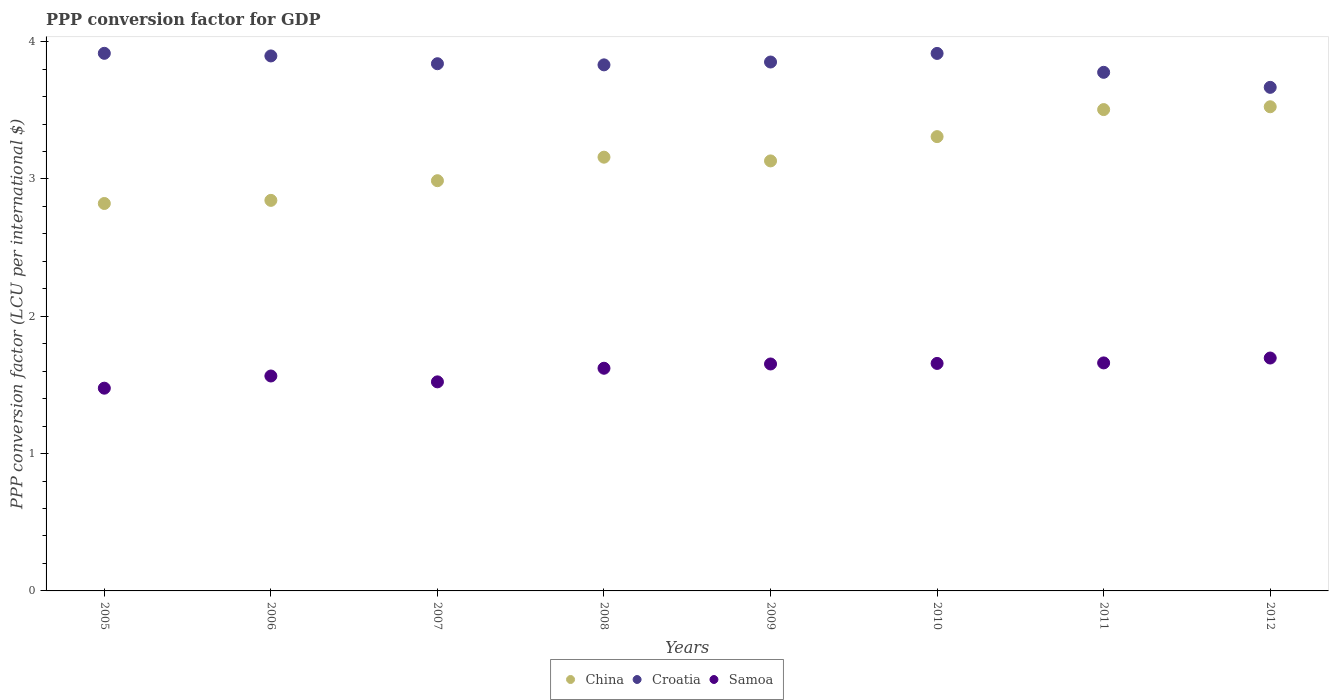Is the number of dotlines equal to the number of legend labels?
Your answer should be very brief. Yes. What is the PPP conversion factor for GDP in Samoa in 2010?
Give a very brief answer. 1.66. Across all years, what is the maximum PPP conversion factor for GDP in Samoa?
Offer a very short reply. 1.7. Across all years, what is the minimum PPP conversion factor for GDP in Samoa?
Make the answer very short. 1.48. In which year was the PPP conversion factor for GDP in Samoa maximum?
Your answer should be very brief. 2012. What is the total PPP conversion factor for GDP in Croatia in the graph?
Give a very brief answer. 30.69. What is the difference between the PPP conversion factor for GDP in China in 2006 and that in 2007?
Your response must be concise. -0.14. What is the difference between the PPP conversion factor for GDP in Croatia in 2008 and the PPP conversion factor for GDP in Samoa in 2010?
Provide a succinct answer. 2.17. What is the average PPP conversion factor for GDP in Samoa per year?
Offer a terse response. 1.61. In the year 2005, what is the difference between the PPP conversion factor for GDP in China and PPP conversion factor for GDP in Samoa?
Provide a short and direct response. 1.35. What is the ratio of the PPP conversion factor for GDP in Croatia in 2006 to that in 2008?
Your answer should be very brief. 1.02. Is the difference between the PPP conversion factor for GDP in China in 2009 and 2012 greater than the difference between the PPP conversion factor for GDP in Samoa in 2009 and 2012?
Ensure brevity in your answer.  No. What is the difference between the highest and the second highest PPP conversion factor for GDP in China?
Ensure brevity in your answer.  0.02. What is the difference between the highest and the lowest PPP conversion factor for GDP in Samoa?
Ensure brevity in your answer.  0.22. In how many years, is the PPP conversion factor for GDP in China greater than the average PPP conversion factor for GDP in China taken over all years?
Provide a short and direct response. 3. Does the PPP conversion factor for GDP in Samoa monotonically increase over the years?
Ensure brevity in your answer.  No. Is the PPP conversion factor for GDP in China strictly less than the PPP conversion factor for GDP in Croatia over the years?
Make the answer very short. Yes. How many years are there in the graph?
Your answer should be compact. 8. Are the values on the major ticks of Y-axis written in scientific E-notation?
Provide a short and direct response. No. Where does the legend appear in the graph?
Keep it short and to the point. Bottom center. How many legend labels are there?
Your answer should be very brief. 3. How are the legend labels stacked?
Offer a terse response. Horizontal. What is the title of the graph?
Offer a terse response. PPP conversion factor for GDP. What is the label or title of the Y-axis?
Your answer should be very brief. PPP conversion factor (LCU per international $). What is the PPP conversion factor (LCU per international $) of China in 2005?
Give a very brief answer. 2.82. What is the PPP conversion factor (LCU per international $) in Croatia in 2005?
Your answer should be compact. 3.92. What is the PPP conversion factor (LCU per international $) of Samoa in 2005?
Your answer should be very brief. 1.48. What is the PPP conversion factor (LCU per international $) of China in 2006?
Offer a terse response. 2.84. What is the PPP conversion factor (LCU per international $) of Croatia in 2006?
Offer a very short reply. 3.9. What is the PPP conversion factor (LCU per international $) of Samoa in 2006?
Your answer should be compact. 1.57. What is the PPP conversion factor (LCU per international $) of China in 2007?
Offer a very short reply. 2.99. What is the PPP conversion factor (LCU per international $) of Croatia in 2007?
Offer a terse response. 3.84. What is the PPP conversion factor (LCU per international $) in Samoa in 2007?
Ensure brevity in your answer.  1.52. What is the PPP conversion factor (LCU per international $) in China in 2008?
Offer a very short reply. 3.16. What is the PPP conversion factor (LCU per international $) in Croatia in 2008?
Keep it short and to the point. 3.83. What is the PPP conversion factor (LCU per international $) in Samoa in 2008?
Offer a terse response. 1.62. What is the PPP conversion factor (LCU per international $) in China in 2009?
Your response must be concise. 3.13. What is the PPP conversion factor (LCU per international $) of Croatia in 2009?
Your answer should be very brief. 3.85. What is the PPP conversion factor (LCU per international $) of Samoa in 2009?
Provide a succinct answer. 1.65. What is the PPP conversion factor (LCU per international $) of China in 2010?
Your answer should be compact. 3.31. What is the PPP conversion factor (LCU per international $) of Croatia in 2010?
Offer a very short reply. 3.91. What is the PPP conversion factor (LCU per international $) in Samoa in 2010?
Offer a very short reply. 1.66. What is the PPP conversion factor (LCU per international $) of China in 2011?
Offer a very short reply. 3.51. What is the PPP conversion factor (LCU per international $) of Croatia in 2011?
Give a very brief answer. 3.78. What is the PPP conversion factor (LCU per international $) in Samoa in 2011?
Provide a succinct answer. 1.66. What is the PPP conversion factor (LCU per international $) of China in 2012?
Your response must be concise. 3.53. What is the PPP conversion factor (LCU per international $) of Croatia in 2012?
Your answer should be compact. 3.67. What is the PPP conversion factor (LCU per international $) of Samoa in 2012?
Provide a short and direct response. 1.7. Across all years, what is the maximum PPP conversion factor (LCU per international $) in China?
Keep it short and to the point. 3.53. Across all years, what is the maximum PPP conversion factor (LCU per international $) of Croatia?
Provide a succinct answer. 3.92. Across all years, what is the maximum PPP conversion factor (LCU per international $) in Samoa?
Make the answer very short. 1.7. Across all years, what is the minimum PPP conversion factor (LCU per international $) in China?
Your answer should be very brief. 2.82. Across all years, what is the minimum PPP conversion factor (LCU per international $) of Croatia?
Provide a succinct answer. 3.67. Across all years, what is the minimum PPP conversion factor (LCU per international $) of Samoa?
Ensure brevity in your answer.  1.48. What is the total PPP conversion factor (LCU per international $) of China in the graph?
Offer a very short reply. 25.28. What is the total PPP conversion factor (LCU per international $) in Croatia in the graph?
Keep it short and to the point. 30.69. What is the total PPP conversion factor (LCU per international $) in Samoa in the graph?
Keep it short and to the point. 12.85. What is the difference between the PPP conversion factor (LCU per international $) of China in 2005 and that in 2006?
Ensure brevity in your answer.  -0.02. What is the difference between the PPP conversion factor (LCU per international $) of Croatia in 2005 and that in 2006?
Offer a very short reply. 0.02. What is the difference between the PPP conversion factor (LCU per international $) of Samoa in 2005 and that in 2006?
Your answer should be compact. -0.09. What is the difference between the PPP conversion factor (LCU per international $) of China in 2005 and that in 2007?
Your answer should be compact. -0.17. What is the difference between the PPP conversion factor (LCU per international $) in Croatia in 2005 and that in 2007?
Keep it short and to the point. 0.08. What is the difference between the PPP conversion factor (LCU per international $) in Samoa in 2005 and that in 2007?
Offer a very short reply. -0.05. What is the difference between the PPP conversion factor (LCU per international $) in China in 2005 and that in 2008?
Your answer should be very brief. -0.34. What is the difference between the PPP conversion factor (LCU per international $) of Croatia in 2005 and that in 2008?
Make the answer very short. 0.08. What is the difference between the PPP conversion factor (LCU per international $) of Samoa in 2005 and that in 2008?
Make the answer very short. -0.15. What is the difference between the PPP conversion factor (LCU per international $) in China in 2005 and that in 2009?
Provide a succinct answer. -0.31. What is the difference between the PPP conversion factor (LCU per international $) in Croatia in 2005 and that in 2009?
Keep it short and to the point. 0.06. What is the difference between the PPP conversion factor (LCU per international $) of Samoa in 2005 and that in 2009?
Keep it short and to the point. -0.18. What is the difference between the PPP conversion factor (LCU per international $) of China in 2005 and that in 2010?
Your response must be concise. -0.49. What is the difference between the PPP conversion factor (LCU per international $) in Croatia in 2005 and that in 2010?
Offer a terse response. 0. What is the difference between the PPP conversion factor (LCU per international $) of Samoa in 2005 and that in 2010?
Offer a terse response. -0.18. What is the difference between the PPP conversion factor (LCU per international $) in China in 2005 and that in 2011?
Your answer should be very brief. -0.68. What is the difference between the PPP conversion factor (LCU per international $) of Croatia in 2005 and that in 2011?
Ensure brevity in your answer.  0.14. What is the difference between the PPP conversion factor (LCU per international $) in Samoa in 2005 and that in 2011?
Your response must be concise. -0.18. What is the difference between the PPP conversion factor (LCU per international $) of China in 2005 and that in 2012?
Your answer should be very brief. -0.7. What is the difference between the PPP conversion factor (LCU per international $) of Croatia in 2005 and that in 2012?
Ensure brevity in your answer.  0.25. What is the difference between the PPP conversion factor (LCU per international $) of Samoa in 2005 and that in 2012?
Offer a terse response. -0.22. What is the difference between the PPP conversion factor (LCU per international $) of China in 2006 and that in 2007?
Offer a terse response. -0.14. What is the difference between the PPP conversion factor (LCU per international $) in Croatia in 2006 and that in 2007?
Offer a very short reply. 0.06. What is the difference between the PPP conversion factor (LCU per international $) of Samoa in 2006 and that in 2007?
Give a very brief answer. 0.04. What is the difference between the PPP conversion factor (LCU per international $) of China in 2006 and that in 2008?
Offer a terse response. -0.31. What is the difference between the PPP conversion factor (LCU per international $) of Croatia in 2006 and that in 2008?
Your answer should be compact. 0.07. What is the difference between the PPP conversion factor (LCU per international $) of Samoa in 2006 and that in 2008?
Give a very brief answer. -0.06. What is the difference between the PPP conversion factor (LCU per international $) in China in 2006 and that in 2009?
Make the answer very short. -0.29. What is the difference between the PPP conversion factor (LCU per international $) of Croatia in 2006 and that in 2009?
Ensure brevity in your answer.  0.04. What is the difference between the PPP conversion factor (LCU per international $) of Samoa in 2006 and that in 2009?
Make the answer very short. -0.09. What is the difference between the PPP conversion factor (LCU per international $) in China in 2006 and that in 2010?
Your answer should be very brief. -0.46. What is the difference between the PPP conversion factor (LCU per international $) of Croatia in 2006 and that in 2010?
Provide a short and direct response. -0.02. What is the difference between the PPP conversion factor (LCU per international $) of Samoa in 2006 and that in 2010?
Give a very brief answer. -0.09. What is the difference between the PPP conversion factor (LCU per international $) in China in 2006 and that in 2011?
Your response must be concise. -0.66. What is the difference between the PPP conversion factor (LCU per international $) in Croatia in 2006 and that in 2011?
Your answer should be compact. 0.12. What is the difference between the PPP conversion factor (LCU per international $) in Samoa in 2006 and that in 2011?
Offer a terse response. -0.1. What is the difference between the PPP conversion factor (LCU per international $) in China in 2006 and that in 2012?
Your response must be concise. -0.68. What is the difference between the PPP conversion factor (LCU per international $) in Croatia in 2006 and that in 2012?
Your answer should be compact. 0.23. What is the difference between the PPP conversion factor (LCU per international $) of Samoa in 2006 and that in 2012?
Give a very brief answer. -0.13. What is the difference between the PPP conversion factor (LCU per international $) of China in 2007 and that in 2008?
Provide a short and direct response. -0.17. What is the difference between the PPP conversion factor (LCU per international $) in Croatia in 2007 and that in 2008?
Make the answer very short. 0.01. What is the difference between the PPP conversion factor (LCU per international $) in Samoa in 2007 and that in 2008?
Provide a succinct answer. -0.1. What is the difference between the PPP conversion factor (LCU per international $) in China in 2007 and that in 2009?
Ensure brevity in your answer.  -0.14. What is the difference between the PPP conversion factor (LCU per international $) in Croatia in 2007 and that in 2009?
Offer a very short reply. -0.01. What is the difference between the PPP conversion factor (LCU per international $) of Samoa in 2007 and that in 2009?
Provide a succinct answer. -0.13. What is the difference between the PPP conversion factor (LCU per international $) of China in 2007 and that in 2010?
Offer a terse response. -0.32. What is the difference between the PPP conversion factor (LCU per international $) in Croatia in 2007 and that in 2010?
Your response must be concise. -0.07. What is the difference between the PPP conversion factor (LCU per international $) in Samoa in 2007 and that in 2010?
Offer a terse response. -0.13. What is the difference between the PPP conversion factor (LCU per international $) of China in 2007 and that in 2011?
Offer a terse response. -0.52. What is the difference between the PPP conversion factor (LCU per international $) in Croatia in 2007 and that in 2011?
Your answer should be very brief. 0.06. What is the difference between the PPP conversion factor (LCU per international $) of Samoa in 2007 and that in 2011?
Ensure brevity in your answer.  -0.14. What is the difference between the PPP conversion factor (LCU per international $) in China in 2007 and that in 2012?
Provide a succinct answer. -0.54. What is the difference between the PPP conversion factor (LCU per international $) of Croatia in 2007 and that in 2012?
Your answer should be compact. 0.17. What is the difference between the PPP conversion factor (LCU per international $) of Samoa in 2007 and that in 2012?
Provide a succinct answer. -0.17. What is the difference between the PPP conversion factor (LCU per international $) of China in 2008 and that in 2009?
Provide a short and direct response. 0.03. What is the difference between the PPP conversion factor (LCU per international $) in Croatia in 2008 and that in 2009?
Your response must be concise. -0.02. What is the difference between the PPP conversion factor (LCU per international $) of Samoa in 2008 and that in 2009?
Offer a very short reply. -0.03. What is the difference between the PPP conversion factor (LCU per international $) in China in 2008 and that in 2010?
Offer a very short reply. -0.15. What is the difference between the PPP conversion factor (LCU per international $) in Croatia in 2008 and that in 2010?
Offer a very short reply. -0.08. What is the difference between the PPP conversion factor (LCU per international $) in Samoa in 2008 and that in 2010?
Your answer should be very brief. -0.04. What is the difference between the PPP conversion factor (LCU per international $) in China in 2008 and that in 2011?
Your response must be concise. -0.35. What is the difference between the PPP conversion factor (LCU per international $) in Croatia in 2008 and that in 2011?
Keep it short and to the point. 0.05. What is the difference between the PPP conversion factor (LCU per international $) of Samoa in 2008 and that in 2011?
Ensure brevity in your answer.  -0.04. What is the difference between the PPP conversion factor (LCU per international $) of China in 2008 and that in 2012?
Keep it short and to the point. -0.37. What is the difference between the PPP conversion factor (LCU per international $) in Croatia in 2008 and that in 2012?
Offer a very short reply. 0.16. What is the difference between the PPP conversion factor (LCU per international $) in Samoa in 2008 and that in 2012?
Make the answer very short. -0.07. What is the difference between the PPP conversion factor (LCU per international $) of China in 2009 and that in 2010?
Make the answer very short. -0.18. What is the difference between the PPP conversion factor (LCU per international $) of Croatia in 2009 and that in 2010?
Your answer should be very brief. -0.06. What is the difference between the PPP conversion factor (LCU per international $) of Samoa in 2009 and that in 2010?
Offer a terse response. -0. What is the difference between the PPP conversion factor (LCU per international $) of China in 2009 and that in 2011?
Provide a short and direct response. -0.37. What is the difference between the PPP conversion factor (LCU per international $) of Croatia in 2009 and that in 2011?
Give a very brief answer. 0.07. What is the difference between the PPP conversion factor (LCU per international $) in Samoa in 2009 and that in 2011?
Your response must be concise. -0.01. What is the difference between the PPP conversion factor (LCU per international $) in China in 2009 and that in 2012?
Provide a short and direct response. -0.39. What is the difference between the PPP conversion factor (LCU per international $) in Croatia in 2009 and that in 2012?
Provide a succinct answer. 0.18. What is the difference between the PPP conversion factor (LCU per international $) in Samoa in 2009 and that in 2012?
Give a very brief answer. -0.04. What is the difference between the PPP conversion factor (LCU per international $) in China in 2010 and that in 2011?
Your answer should be very brief. -0.2. What is the difference between the PPP conversion factor (LCU per international $) in Croatia in 2010 and that in 2011?
Offer a terse response. 0.14. What is the difference between the PPP conversion factor (LCU per international $) of Samoa in 2010 and that in 2011?
Your answer should be very brief. -0. What is the difference between the PPP conversion factor (LCU per international $) of China in 2010 and that in 2012?
Your answer should be compact. -0.22. What is the difference between the PPP conversion factor (LCU per international $) in Croatia in 2010 and that in 2012?
Offer a terse response. 0.25. What is the difference between the PPP conversion factor (LCU per international $) in Samoa in 2010 and that in 2012?
Offer a terse response. -0.04. What is the difference between the PPP conversion factor (LCU per international $) in China in 2011 and that in 2012?
Offer a terse response. -0.02. What is the difference between the PPP conversion factor (LCU per international $) in Croatia in 2011 and that in 2012?
Your answer should be very brief. 0.11. What is the difference between the PPP conversion factor (LCU per international $) of Samoa in 2011 and that in 2012?
Your answer should be compact. -0.04. What is the difference between the PPP conversion factor (LCU per international $) in China in 2005 and the PPP conversion factor (LCU per international $) in Croatia in 2006?
Keep it short and to the point. -1.07. What is the difference between the PPP conversion factor (LCU per international $) in China in 2005 and the PPP conversion factor (LCU per international $) in Samoa in 2006?
Your response must be concise. 1.26. What is the difference between the PPP conversion factor (LCU per international $) of Croatia in 2005 and the PPP conversion factor (LCU per international $) of Samoa in 2006?
Your answer should be very brief. 2.35. What is the difference between the PPP conversion factor (LCU per international $) of China in 2005 and the PPP conversion factor (LCU per international $) of Croatia in 2007?
Your response must be concise. -1.02. What is the difference between the PPP conversion factor (LCU per international $) of China in 2005 and the PPP conversion factor (LCU per international $) of Samoa in 2007?
Give a very brief answer. 1.3. What is the difference between the PPP conversion factor (LCU per international $) in Croatia in 2005 and the PPP conversion factor (LCU per international $) in Samoa in 2007?
Offer a very short reply. 2.39. What is the difference between the PPP conversion factor (LCU per international $) of China in 2005 and the PPP conversion factor (LCU per international $) of Croatia in 2008?
Keep it short and to the point. -1.01. What is the difference between the PPP conversion factor (LCU per international $) of China in 2005 and the PPP conversion factor (LCU per international $) of Samoa in 2008?
Ensure brevity in your answer.  1.2. What is the difference between the PPP conversion factor (LCU per international $) in Croatia in 2005 and the PPP conversion factor (LCU per international $) in Samoa in 2008?
Provide a short and direct response. 2.29. What is the difference between the PPP conversion factor (LCU per international $) of China in 2005 and the PPP conversion factor (LCU per international $) of Croatia in 2009?
Provide a short and direct response. -1.03. What is the difference between the PPP conversion factor (LCU per international $) of China in 2005 and the PPP conversion factor (LCU per international $) of Samoa in 2009?
Your response must be concise. 1.17. What is the difference between the PPP conversion factor (LCU per international $) in Croatia in 2005 and the PPP conversion factor (LCU per international $) in Samoa in 2009?
Your answer should be very brief. 2.26. What is the difference between the PPP conversion factor (LCU per international $) of China in 2005 and the PPP conversion factor (LCU per international $) of Croatia in 2010?
Offer a very short reply. -1.09. What is the difference between the PPP conversion factor (LCU per international $) of China in 2005 and the PPP conversion factor (LCU per international $) of Samoa in 2010?
Ensure brevity in your answer.  1.16. What is the difference between the PPP conversion factor (LCU per international $) of Croatia in 2005 and the PPP conversion factor (LCU per international $) of Samoa in 2010?
Make the answer very short. 2.26. What is the difference between the PPP conversion factor (LCU per international $) in China in 2005 and the PPP conversion factor (LCU per international $) in Croatia in 2011?
Provide a short and direct response. -0.96. What is the difference between the PPP conversion factor (LCU per international $) in China in 2005 and the PPP conversion factor (LCU per international $) in Samoa in 2011?
Provide a short and direct response. 1.16. What is the difference between the PPP conversion factor (LCU per international $) of Croatia in 2005 and the PPP conversion factor (LCU per international $) of Samoa in 2011?
Keep it short and to the point. 2.25. What is the difference between the PPP conversion factor (LCU per international $) of China in 2005 and the PPP conversion factor (LCU per international $) of Croatia in 2012?
Give a very brief answer. -0.85. What is the difference between the PPP conversion factor (LCU per international $) of China in 2005 and the PPP conversion factor (LCU per international $) of Samoa in 2012?
Offer a terse response. 1.13. What is the difference between the PPP conversion factor (LCU per international $) of Croatia in 2005 and the PPP conversion factor (LCU per international $) of Samoa in 2012?
Ensure brevity in your answer.  2.22. What is the difference between the PPP conversion factor (LCU per international $) of China in 2006 and the PPP conversion factor (LCU per international $) of Croatia in 2007?
Your answer should be very brief. -1. What is the difference between the PPP conversion factor (LCU per international $) of China in 2006 and the PPP conversion factor (LCU per international $) of Samoa in 2007?
Offer a very short reply. 1.32. What is the difference between the PPP conversion factor (LCU per international $) of Croatia in 2006 and the PPP conversion factor (LCU per international $) of Samoa in 2007?
Keep it short and to the point. 2.37. What is the difference between the PPP conversion factor (LCU per international $) of China in 2006 and the PPP conversion factor (LCU per international $) of Croatia in 2008?
Your answer should be very brief. -0.99. What is the difference between the PPP conversion factor (LCU per international $) in China in 2006 and the PPP conversion factor (LCU per international $) in Samoa in 2008?
Ensure brevity in your answer.  1.22. What is the difference between the PPP conversion factor (LCU per international $) of Croatia in 2006 and the PPP conversion factor (LCU per international $) of Samoa in 2008?
Provide a short and direct response. 2.27. What is the difference between the PPP conversion factor (LCU per international $) in China in 2006 and the PPP conversion factor (LCU per international $) in Croatia in 2009?
Your answer should be very brief. -1.01. What is the difference between the PPP conversion factor (LCU per international $) of China in 2006 and the PPP conversion factor (LCU per international $) of Samoa in 2009?
Your answer should be compact. 1.19. What is the difference between the PPP conversion factor (LCU per international $) in Croatia in 2006 and the PPP conversion factor (LCU per international $) in Samoa in 2009?
Provide a short and direct response. 2.24. What is the difference between the PPP conversion factor (LCU per international $) of China in 2006 and the PPP conversion factor (LCU per international $) of Croatia in 2010?
Your response must be concise. -1.07. What is the difference between the PPP conversion factor (LCU per international $) in China in 2006 and the PPP conversion factor (LCU per international $) in Samoa in 2010?
Your response must be concise. 1.19. What is the difference between the PPP conversion factor (LCU per international $) in Croatia in 2006 and the PPP conversion factor (LCU per international $) in Samoa in 2010?
Ensure brevity in your answer.  2.24. What is the difference between the PPP conversion factor (LCU per international $) of China in 2006 and the PPP conversion factor (LCU per international $) of Croatia in 2011?
Give a very brief answer. -0.93. What is the difference between the PPP conversion factor (LCU per international $) in China in 2006 and the PPP conversion factor (LCU per international $) in Samoa in 2011?
Your answer should be very brief. 1.18. What is the difference between the PPP conversion factor (LCU per international $) in Croatia in 2006 and the PPP conversion factor (LCU per international $) in Samoa in 2011?
Your answer should be compact. 2.24. What is the difference between the PPP conversion factor (LCU per international $) in China in 2006 and the PPP conversion factor (LCU per international $) in Croatia in 2012?
Offer a terse response. -0.82. What is the difference between the PPP conversion factor (LCU per international $) of China in 2006 and the PPP conversion factor (LCU per international $) of Samoa in 2012?
Give a very brief answer. 1.15. What is the difference between the PPP conversion factor (LCU per international $) in Croatia in 2006 and the PPP conversion factor (LCU per international $) in Samoa in 2012?
Keep it short and to the point. 2.2. What is the difference between the PPP conversion factor (LCU per international $) in China in 2007 and the PPP conversion factor (LCU per international $) in Croatia in 2008?
Provide a short and direct response. -0.84. What is the difference between the PPP conversion factor (LCU per international $) in China in 2007 and the PPP conversion factor (LCU per international $) in Samoa in 2008?
Your answer should be compact. 1.37. What is the difference between the PPP conversion factor (LCU per international $) of Croatia in 2007 and the PPP conversion factor (LCU per international $) of Samoa in 2008?
Give a very brief answer. 2.22. What is the difference between the PPP conversion factor (LCU per international $) in China in 2007 and the PPP conversion factor (LCU per international $) in Croatia in 2009?
Your response must be concise. -0.86. What is the difference between the PPP conversion factor (LCU per international $) in China in 2007 and the PPP conversion factor (LCU per international $) in Samoa in 2009?
Offer a very short reply. 1.33. What is the difference between the PPP conversion factor (LCU per international $) in Croatia in 2007 and the PPP conversion factor (LCU per international $) in Samoa in 2009?
Provide a short and direct response. 2.19. What is the difference between the PPP conversion factor (LCU per international $) in China in 2007 and the PPP conversion factor (LCU per international $) in Croatia in 2010?
Offer a terse response. -0.93. What is the difference between the PPP conversion factor (LCU per international $) in China in 2007 and the PPP conversion factor (LCU per international $) in Samoa in 2010?
Give a very brief answer. 1.33. What is the difference between the PPP conversion factor (LCU per international $) in Croatia in 2007 and the PPP conversion factor (LCU per international $) in Samoa in 2010?
Provide a succinct answer. 2.18. What is the difference between the PPP conversion factor (LCU per international $) of China in 2007 and the PPP conversion factor (LCU per international $) of Croatia in 2011?
Provide a succinct answer. -0.79. What is the difference between the PPP conversion factor (LCU per international $) in China in 2007 and the PPP conversion factor (LCU per international $) in Samoa in 2011?
Your answer should be very brief. 1.33. What is the difference between the PPP conversion factor (LCU per international $) of Croatia in 2007 and the PPP conversion factor (LCU per international $) of Samoa in 2011?
Your answer should be compact. 2.18. What is the difference between the PPP conversion factor (LCU per international $) in China in 2007 and the PPP conversion factor (LCU per international $) in Croatia in 2012?
Your response must be concise. -0.68. What is the difference between the PPP conversion factor (LCU per international $) of China in 2007 and the PPP conversion factor (LCU per international $) of Samoa in 2012?
Your answer should be compact. 1.29. What is the difference between the PPP conversion factor (LCU per international $) in Croatia in 2007 and the PPP conversion factor (LCU per international $) in Samoa in 2012?
Make the answer very short. 2.14. What is the difference between the PPP conversion factor (LCU per international $) in China in 2008 and the PPP conversion factor (LCU per international $) in Croatia in 2009?
Your answer should be compact. -0.69. What is the difference between the PPP conversion factor (LCU per international $) in China in 2008 and the PPP conversion factor (LCU per international $) in Samoa in 2009?
Your answer should be very brief. 1.51. What is the difference between the PPP conversion factor (LCU per international $) in Croatia in 2008 and the PPP conversion factor (LCU per international $) in Samoa in 2009?
Provide a succinct answer. 2.18. What is the difference between the PPP conversion factor (LCU per international $) in China in 2008 and the PPP conversion factor (LCU per international $) in Croatia in 2010?
Offer a very short reply. -0.76. What is the difference between the PPP conversion factor (LCU per international $) in China in 2008 and the PPP conversion factor (LCU per international $) in Samoa in 2010?
Ensure brevity in your answer.  1.5. What is the difference between the PPP conversion factor (LCU per international $) in Croatia in 2008 and the PPP conversion factor (LCU per international $) in Samoa in 2010?
Your answer should be very brief. 2.17. What is the difference between the PPP conversion factor (LCU per international $) of China in 2008 and the PPP conversion factor (LCU per international $) of Croatia in 2011?
Your response must be concise. -0.62. What is the difference between the PPP conversion factor (LCU per international $) of China in 2008 and the PPP conversion factor (LCU per international $) of Samoa in 2011?
Provide a succinct answer. 1.5. What is the difference between the PPP conversion factor (LCU per international $) of Croatia in 2008 and the PPP conversion factor (LCU per international $) of Samoa in 2011?
Keep it short and to the point. 2.17. What is the difference between the PPP conversion factor (LCU per international $) in China in 2008 and the PPP conversion factor (LCU per international $) in Croatia in 2012?
Ensure brevity in your answer.  -0.51. What is the difference between the PPP conversion factor (LCU per international $) in China in 2008 and the PPP conversion factor (LCU per international $) in Samoa in 2012?
Keep it short and to the point. 1.46. What is the difference between the PPP conversion factor (LCU per international $) in Croatia in 2008 and the PPP conversion factor (LCU per international $) in Samoa in 2012?
Your answer should be compact. 2.14. What is the difference between the PPP conversion factor (LCU per international $) of China in 2009 and the PPP conversion factor (LCU per international $) of Croatia in 2010?
Provide a short and direct response. -0.78. What is the difference between the PPP conversion factor (LCU per international $) of China in 2009 and the PPP conversion factor (LCU per international $) of Samoa in 2010?
Give a very brief answer. 1.47. What is the difference between the PPP conversion factor (LCU per international $) of Croatia in 2009 and the PPP conversion factor (LCU per international $) of Samoa in 2010?
Give a very brief answer. 2.2. What is the difference between the PPP conversion factor (LCU per international $) of China in 2009 and the PPP conversion factor (LCU per international $) of Croatia in 2011?
Make the answer very short. -0.65. What is the difference between the PPP conversion factor (LCU per international $) in China in 2009 and the PPP conversion factor (LCU per international $) in Samoa in 2011?
Give a very brief answer. 1.47. What is the difference between the PPP conversion factor (LCU per international $) of Croatia in 2009 and the PPP conversion factor (LCU per international $) of Samoa in 2011?
Give a very brief answer. 2.19. What is the difference between the PPP conversion factor (LCU per international $) of China in 2009 and the PPP conversion factor (LCU per international $) of Croatia in 2012?
Give a very brief answer. -0.54. What is the difference between the PPP conversion factor (LCU per international $) of China in 2009 and the PPP conversion factor (LCU per international $) of Samoa in 2012?
Make the answer very short. 1.44. What is the difference between the PPP conversion factor (LCU per international $) of Croatia in 2009 and the PPP conversion factor (LCU per international $) of Samoa in 2012?
Keep it short and to the point. 2.16. What is the difference between the PPP conversion factor (LCU per international $) in China in 2010 and the PPP conversion factor (LCU per international $) in Croatia in 2011?
Your answer should be very brief. -0.47. What is the difference between the PPP conversion factor (LCU per international $) of China in 2010 and the PPP conversion factor (LCU per international $) of Samoa in 2011?
Make the answer very short. 1.65. What is the difference between the PPP conversion factor (LCU per international $) of Croatia in 2010 and the PPP conversion factor (LCU per international $) of Samoa in 2011?
Make the answer very short. 2.25. What is the difference between the PPP conversion factor (LCU per international $) in China in 2010 and the PPP conversion factor (LCU per international $) in Croatia in 2012?
Give a very brief answer. -0.36. What is the difference between the PPP conversion factor (LCU per international $) in China in 2010 and the PPP conversion factor (LCU per international $) in Samoa in 2012?
Offer a terse response. 1.61. What is the difference between the PPP conversion factor (LCU per international $) in Croatia in 2010 and the PPP conversion factor (LCU per international $) in Samoa in 2012?
Provide a succinct answer. 2.22. What is the difference between the PPP conversion factor (LCU per international $) in China in 2011 and the PPP conversion factor (LCU per international $) in Croatia in 2012?
Your answer should be very brief. -0.16. What is the difference between the PPP conversion factor (LCU per international $) in China in 2011 and the PPP conversion factor (LCU per international $) in Samoa in 2012?
Keep it short and to the point. 1.81. What is the difference between the PPP conversion factor (LCU per international $) of Croatia in 2011 and the PPP conversion factor (LCU per international $) of Samoa in 2012?
Give a very brief answer. 2.08. What is the average PPP conversion factor (LCU per international $) in China per year?
Provide a short and direct response. 3.16. What is the average PPP conversion factor (LCU per international $) of Croatia per year?
Provide a succinct answer. 3.84. What is the average PPP conversion factor (LCU per international $) of Samoa per year?
Keep it short and to the point. 1.61. In the year 2005, what is the difference between the PPP conversion factor (LCU per international $) in China and PPP conversion factor (LCU per international $) in Croatia?
Provide a succinct answer. -1.09. In the year 2005, what is the difference between the PPP conversion factor (LCU per international $) in China and PPP conversion factor (LCU per international $) in Samoa?
Give a very brief answer. 1.35. In the year 2005, what is the difference between the PPP conversion factor (LCU per international $) of Croatia and PPP conversion factor (LCU per international $) of Samoa?
Provide a succinct answer. 2.44. In the year 2006, what is the difference between the PPP conversion factor (LCU per international $) in China and PPP conversion factor (LCU per international $) in Croatia?
Offer a terse response. -1.05. In the year 2006, what is the difference between the PPP conversion factor (LCU per international $) of China and PPP conversion factor (LCU per international $) of Samoa?
Keep it short and to the point. 1.28. In the year 2006, what is the difference between the PPP conversion factor (LCU per international $) in Croatia and PPP conversion factor (LCU per international $) in Samoa?
Provide a short and direct response. 2.33. In the year 2007, what is the difference between the PPP conversion factor (LCU per international $) in China and PPP conversion factor (LCU per international $) in Croatia?
Provide a succinct answer. -0.85. In the year 2007, what is the difference between the PPP conversion factor (LCU per international $) in China and PPP conversion factor (LCU per international $) in Samoa?
Your response must be concise. 1.47. In the year 2007, what is the difference between the PPP conversion factor (LCU per international $) of Croatia and PPP conversion factor (LCU per international $) of Samoa?
Make the answer very short. 2.32. In the year 2008, what is the difference between the PPP conversion factor (LCU per international $) of China and PPP conversion factor (LCU per international $) of Croatia?
Provide a succinct answer. -0.67. In the year 2008, what is the difference between the PPP conversion factor (LCU per international $) in China and PPP conversion factor (LCU per international $) in Samoa?
Your answer should be compact. 1.54. In the year 2008, what is the difference between the PPP conversion factor (LCU per international $) of Croatia and PPP conversion factor (LCU per international $) of Samoa?
Give a very brief answer. 2.21. In the year 2009, what is the difference between the PPP conversion factor (LCU per international $) of China and PPP conversion factor (LCU per international $) of Croatia?
Provide a succinct answer. -0.72. In the year 2009, what is the difference between the PPP conversion factor (LCU per international $) of China and PPP conversion factor (LCU per international $) of Samoa?
Provide a short and direct response. 1.48. In the year 2009, what is the difference between the PPP conversion factor (LCU per international $) of Croatia and PPP conversion factor (LCU per international $) of Samoa?
Offer a terse response. 2.2. In the year 2010, what is the difference between the PPP conversion factor (LCU per international $) in China and PPP conversion factor (LCU per international $) in Croatia?
Keep it short and to the point. -0.61. In the year 2010, what is the difference between the PPP conversion factor (LCU per international $) in China and PPP conversion factor (LCU per international $) in Samoa?
Keep it short and to the point. 1.65. In the year 2010, what is the difference between the PPP conversion factor (LCU per international $) of Croatia and PPP conversion factor (LCU per international $) of Samoa?
Give a very brief answer. 2.26. In the year 2011, what is the difference between the PPP conversion factor (LCU per international $) of China and PPP conversion factor (LCU per international $) of Croatia?
Your response must be concise. -0.27. In the year 2011, what is the difference between the PPP conversion factor (LCU per international $) of China and PPP conversion factor (LCU per international $) of Samoa?
Offer a terse response. 1.84. In the year 2011, what is the difference between the PPP conversion factor (LCU per international $) of Croatia and PPP conversion factor (LCU per international $) of Samoa?
Ensure brevity in your answer.  2.12. In the year 2012, what is the difference between the PPP conversion factor (LCU per international $) of China and PPP conversion factor (LCU per international $) of Croatia?
Offer a very short reply. -0.14. In the year 2012, what is the difference between the PPP conversion factor (LCU per international $) of China and PPP conversion factor (LCU per international $) of Samoa?
Your answer should be compact. 1.83. In the year 2012, what is the difference between the PPP conversion factor (LCU per international $) of Croatia and PPP conversion factor (LCU per international $) of Samoa?
Provide a succinct answer. 1.97. What is the ratio of the PPP conversion factor (LCU per international $) of Samoa in 2005 to that in 2006?
Provide a short and direct response. 0.94. What is the ratio of the PPP conversion factor (LCU per international $) of China in 2005 to that in 2007?
Your answer should be compact. 0.94. What is the ratio of the PPP conversion factor (LCU per international $) in Croatia in 2005 to that in 2007?
Ensure brevity in your answer.  1.02. What is the ratio of the PPP conversion factor (LCU per international $) in Samoa in 2005 to that in 2007?
Your response must be concise. 0.97. What is the ratio of the PPP conversion factor (LCU per international $) of China in 2005 to that in 2008?
Make the answer very short. 0.89. What is the ratio of the PPP conversion factor (LCU per international $) in Croatia in 2005 to that in 2008?
Make the answer very short. 1.02. What is the ratio of the PPP conversion factor (LCU per international $) of Samoa in 2005 to that in 2008?
Provide a short and direct response. 0.91. What is the ratio of the PPP conversion factor (LCU per international $) in China in 2005 to that in 2009?
Your answer should be very brief. 0.9. What is the ratio of the PPP conversion factor (LCU per international $) in Croatia in 2005 to that in 2009?
Keep it short and to the point. 1.02. What is the ratio of the PPP conversion factor (LCU per international $) in Samoa in 2005 to that in 2009?
Provide a short and direct response. 0.89. What is the ratio of the PPP conversion factor (LCU per international $) in China in 2005 to that in 2010?
Provide a succinct answer. 0.85. What is the ratio of the PPP conversion factor (LCU per international $) of Croatia in 2005 to that in 2010?
Make the answer very short. 1. What is the ratio of the PPP conversion factor (LCU per international $) of Samoa in 2005 to that in 2010?
Provide a succinct answer. 0.89. What is the ratio of the PPP conversion factor (LCU per international $) in China in 2005 to that in 2011?
Give a very brief answer. 0.8. What is the ratio of the PPP conversion factor (LCU per international $) of Croatia in 2005 to that in 2011?
Your response must be concise. 1.04. What is the ratio of the PPP conversion factor (LCU per international $) of Samoa in 2005 to that in 2011?
Make the answer very short. 0.89. What is the ratio of the PPP conversion factor (LCU per international $) of China in 2005 to that in 2012?
Your answer should be compact. 0.8. What is the ratio of the PPP conversion factor (LCU per international $) of Croatia in 2005 to that in 2012?
Ensure brevity in your answer.  1.07. What is the ratio of the PPP conversion factor (LCU per international $) of Samoa in 2005 to that in 2012?
Your response must be concise. 0.87. What is the ratio of the PPP conversion factor (LCU per international $) of China in 2006 to that in 2007?
Make the answer very short. 0.95. What is the ratio of the PPP conversion factor (LCU per international $) of Croatia in 2006 to that in 2007?
Provide a succinct answer. 1.01. What is the ratio of the PPP conversion factor (LCU per international $) of Samoa in 2006 to that in 2007?
Offer a very short reply. 1.03. What is the ratio of the PPP conversion factor (LCU per international $) in China in 2006 to that in 2008?
Make the answer very short. 0.9. What is the ratio of the PPP conversion factor (LCU per international $) of Samoa in 2006 to that in 2008?
Your answer should be compact. 0.97. What is the ratio of the PPP conversion factor (LCU per international $) in China in 2006 to that in 2009?
Your answer should be very brief. 0.91. What is the ratio of the PPP conversion factor (LCU per international $) in Croatia in 2006 to that in 2009?
Offer a terse response. 1.01. What is the ratio of the PPP conversion factor (LCU per international $) of Samoa in 2006 to that in 2009?
Offer a terse response. 0.95. What is the ratio of the PPP conversion factor (LCU per international $) of China in 2006 to that in 2010?
Provide a succinct answer. 0.86. What is the ratio of the PPP conversion factor (LCU per international $) of Croatia in 2006 to that in 2010?
Make the answer very short. 1. What is the ratio of the PPP conversion factor (LCU per international $) in Samoa in 2006 to that in 2010?
Offer a very short reply. 0.94. What is the ratio of the PPP conversion factor (LCU per international $) in China in 2006 to that in 2011?
Offer a very short reply. 0.81. What is the ratio of the PPP conversion factor (LCU per international $) of Croatia in 2006 to that in 2011?
Offer a very short reply. 1.03. What is the ratio of the PPP conversion factor (LCU per international $) of Samoa in 2006 to that in 2011?
Provide a short and direct response. 0.94. What is the ratio of the PPP conversion factor (LCU per international $) in China in 2006 to that in 2012?
Make the answer very short. 0.81. What is the ratio of the PPP conversion factor (LCU per international $) in Croatia in 2006 to that in 2012?
Give a very brief answer. 1.06. What is the ratio of the PPP conversion factor (LCU per international $) in Samoa in 2006 to that in 2012?
Offer a very short reply. 0.92. What is the ratio of the PPP conversion factor (LCU per international $) of China in 2007 to that in 2008?
Offer a very short reply. 0.95. What is the ratio of the PPP conversion factor (LCU per international $) in Croatia in 2007 to that in 2008?
Offer a very short reply. 1. What is the ratio of the PPP conversion factor (LCU per international $) of Samoa in 2007 to that in 2008?
Your answer should be compact. 0.94. What is the ratio of the PPP conversion factor (LCU per international $) in China in 2007 to that in 2009?
Your answer should be very brief. 0.95. What is the ratio of the PPP conversion factor (LCU per international $) in Croatia in 2007 to that in 2009?
Offer a very short reply. 1. What is the ratio of the PPP conversion factor (LCU per international $) in Samoa in 2007 to that in 2009?
Provide a succinct answer. 0.92. What is the ratio of the PPP conversion factor (LCU per international $) of China in 2007 to that in 2010?
Give a very brief answer. 0.9. What is the ratio of the PPP conversion factor (LCU per international $) of Croatia in 2007 to that in 2010?
Make the answer very short. 0.98. What is the ratio of the PPP conversion factor (LCU per international $) of Samoa in 2007 to that in 2010?
Offer a very short reply. 0.92. What is the ratio of the PPP conversion factor (LCU per international $) of China in 2007 to that in 2011?
Your answer should be very brief. 0.85. What is the ratio of the PPP conversion factor (LCU per international $) in Croatia in 2007 to that in 2011?
Offer a very short reply. 1.02. What is the ratio of the PPP conversion factor (LCU per international $) in Samoa in 2007 to that in 2011?
Ensure brevity in your answer.  0.92. What is the ratio of the PPP conversion factor (LCU per international $) of China in 2007 to that in 2012?
Provide a short and direct response. 0.85. What is the ratio of the PPP conversion factor (LCU per international $) of Croatia in 2007 to that in 2012?
Offer a terse response. 1.05. What is the ratio of the PPP conversion factor (LCU per international $) of Samoa in 2007 to that in 2012?
Your answer should be very brief. 0.9. What is the ratio of the PPP conversion factor (LCU per international $) of China in 2008 to that in 2009?
Offer a very short reply. 1.01. What is the ratio of the PPP conversion factor (LCU per international $) in Croatia in 2008 to that in 2009?
Provide a succinct answer. 0.99. What is the ratio of the PPP conversion factor (LCU per international $) of Samoa in 2008 to that in 2009?
Your answer should be compact. 0.98. What is the ratio of the PPP conversion factor (LCU per international $) of China in 2008 to that in 2010?
Your answer should be compact. 0.95. What is the ratio of the PPP conversion factor (LCU per international $) in Croatia in 2008 to that in 2010?
Provide a succinct answer. 0.98. What is the ratio of the PPP conversion factor (LCU per international $) in Samoa in 2008 to that in 2010?
Keep it short and to the point. 0.98. What is the ratio of the PPP conversion factor (LCU per international $) in China in 2008 to that in 2011?
Provide a short and direct response. 0.9. What is the ratio of the PPP conversion factor (LCU per international $) of Croatia in 2008 to that in 2011?
Provide a short and direct response. 1.01. What is the ratio of the PPP conversion factor (LCU per international $) in Samoa in 2008 to that in 2011?
Offer a terse response. 0.98. What is the ratio of the PPP conversion factor (LCU per international $) of China in 2008 to that in 2012?
Your answer should be very brief. 0.9. What is the ratio of the PPP conversion factor (LCU per international $) in Croatia in 2008 to that in 2012?
Offer a very short reply. 1.04. What is the ratio of the PPP conversion factor (LCU per international $) of Samoa in 2008 to that in 2012?
Give a very brief answer. 0.96. What is the ratio of the PPP conversion factor (LCU per international $) of China in 2009 to that in 2010?
Offer a terse response. 0.95. What is the ratio of the PPP conversion factor (LCU per international $) of Samoa in 2009 to that in 2010?
Offer a terse response. 1. What is the ratio of the PPP conversion factor (LCU per international $) of China in 2009 to that in 2011?
Your answer should be compact. 0.89. What is the ratio of the PPP conversion factor (LCU per international $) in Croatia in 2009 to that in 2011?
Your response must be concise. 1.02. What is the ratio of the PPP conversion factor (LCU per international $) of China in 2009 to that in 2012?
Your answer should be very brief. 0.89. What is the ratio of the PPP conversion factor (LCU per international $) in Croatia in 2009 to that in 2012?
Your answer should be compact. 1.05. What is the ratio of the PPP conversion factor (LCU per international $) in Samoa in 2009 to that in 2012?
Your answer should be compact. 0.97. What is the ratio of the PPP conversion factor (LCU per international $) in China in 2010 to that in 2011?
Keep it short and to the point. 0.94. What is the ratio of the PPP conversion factor (LCU per international $) in Croatia in 2010 to that in 2011?
Offer a terse response. 1.04. What is the ratio of the PPP conversion factor (LCU per international $) of Samoa in 2010 to that in 2011?
Keep it short and to the point. 1. What is the ratio of the PPP conversion factor (LCU per international $) of China in 2010 to that in 2012?
Offer a very short reply. 0.94. What is the ratio of the PPP conversion factor (LCU per international $) in Croatia in 2010 to that in 2012?
Ensure brevity in your answer.  1.07. What is the ratio of the PPP conversion factor (LCU per international $) of Samoa in 2010 to that in 2012?
Give a very brief answer. 0.98. What is the ratio of the PPP conversion factor (LCU per international $) of Croatia in 2011 to that in 2012?
Provide a short and direct response. 1.03. What is the ratio of the PPP conversion factor (LCU per international $) in Samoa in 2011 to that in 2012?
Your answer should be compact. 0.98. What is the difference between the highest and the second highest PPP conversion factor (LCU per international $) of China?
Your response must be concise. 0.02. What is the difference between the highest and the second highest PPP conversion factor (LCU per international $) of Croatia?
Give a very brief answer. 0. What is the difference between the highest and the second highest PPP conversion factor (LCU per international $) in Samoa?
Your answer should be very brief. 0.04. What is the difference between the highest and the lowest PPP conversion factor (LCU per international $) in China?
Ensure brevity in your answer.  0.7. What is the difference between the highest and the lowest PPP conversion factor (LCU per international $) in Croatia?
Your answer should be compact. 0.25. What is the difference between the highest and the lowest PPP conversion factor (LCU per international $) of Samoa?
Provide a short and direct response. 0.22. 